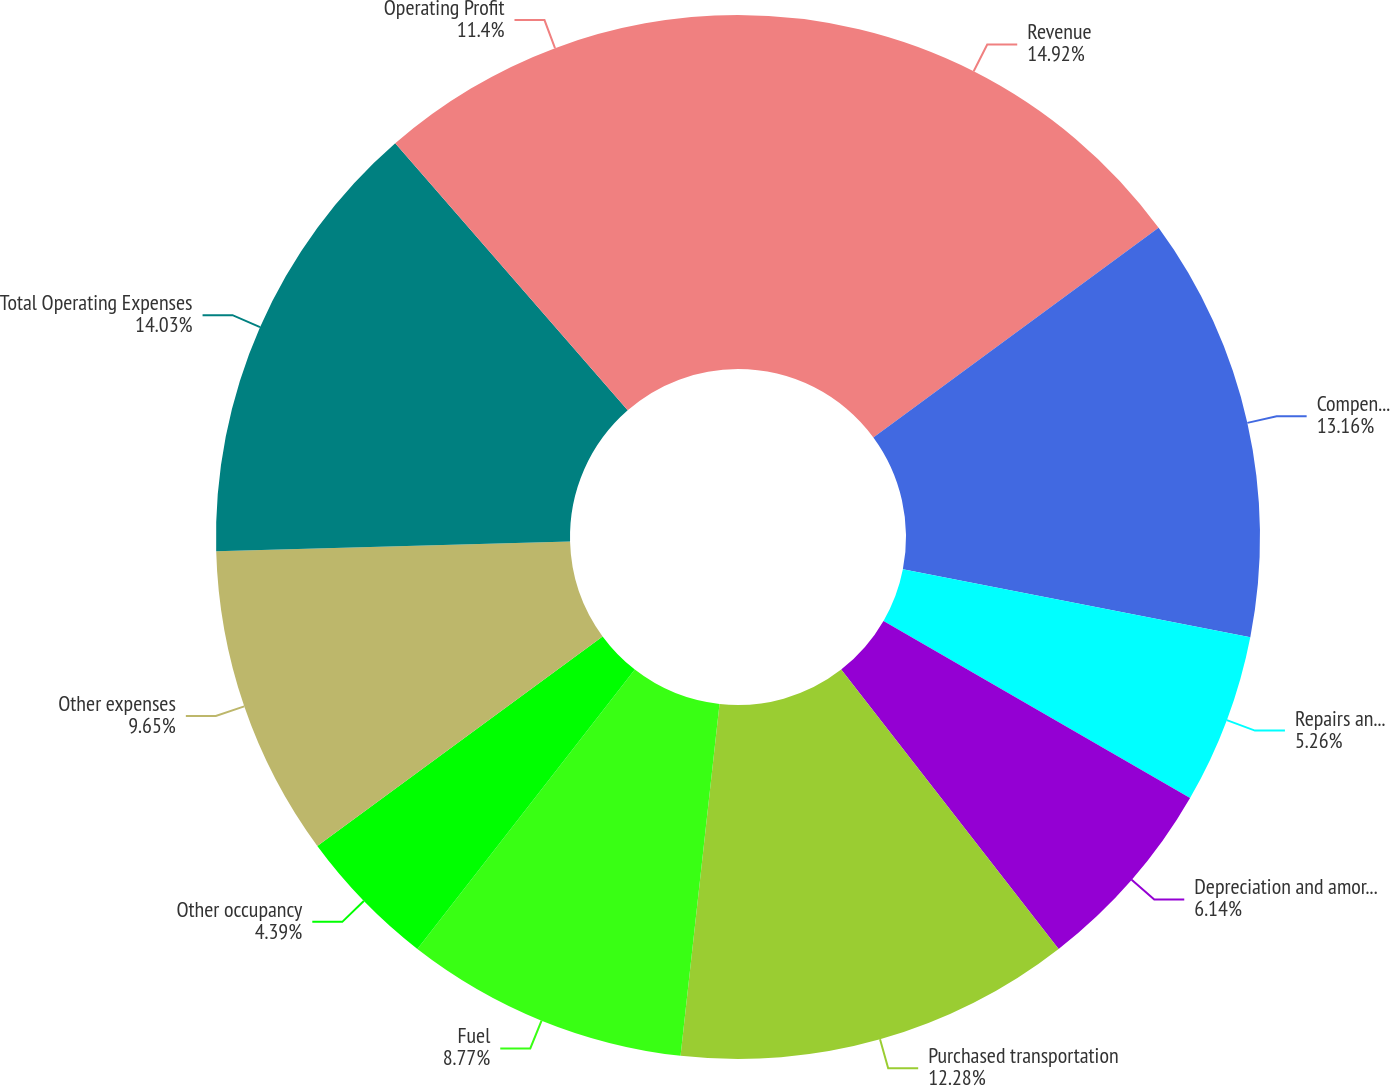Convert chart. <chart><loc_0><loc_0><loc_500><loc_500><pie_chart><fcel>Revenue<fcel>Compensation and benefits<fcel>Repairs and maintenance<fcel>Depreciation and amortization<fcel>Purchased transportation<fcel>Fuel<fcel>Other occupancy<fcel>Other expenses<fcel>Total Operating Expenses<fcel>Operating Profit<nl><fcel>14.91%<fcel>13.16%<fcel>5.26%<fcel>6.14%<fcel>12.28%<fcel>8.77%<fcel>4.39%<fcel>9.65%<fcel>14.03%<fcel>11.4%<nl></chart> 